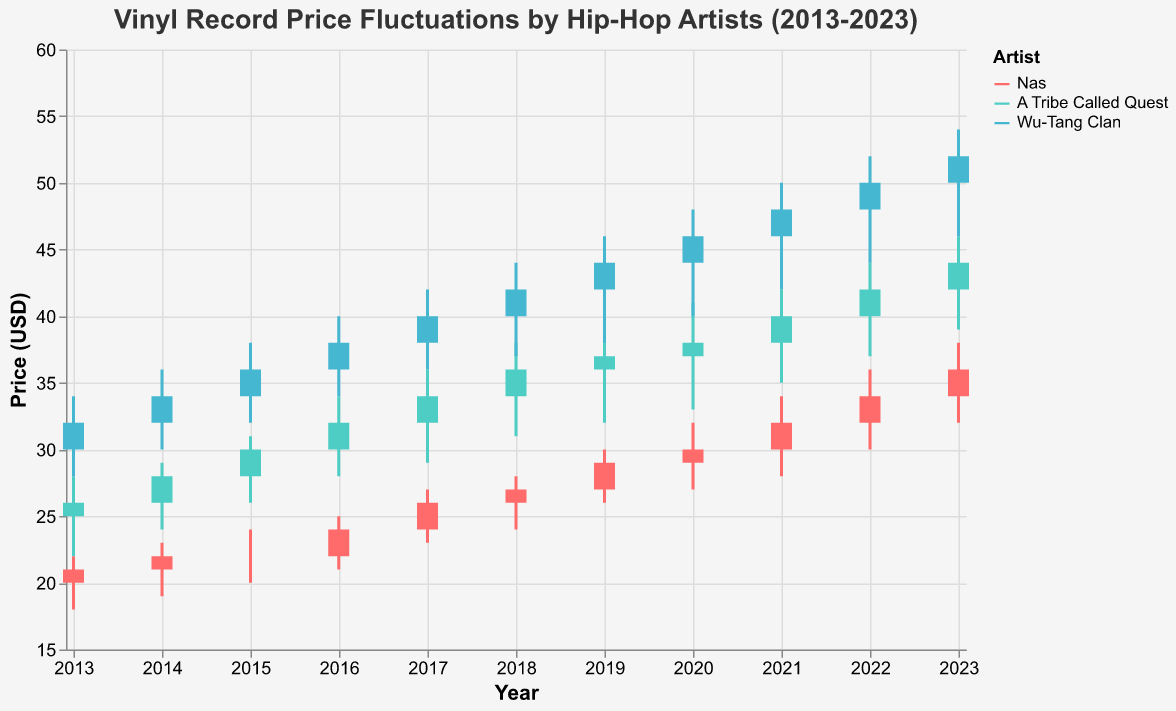How has the price of Nas's vinyl records changed from 2013 to 2023? The candlestick plot shows that in 2013, Nas's records opened at $20 and closed at $21. By 2023, they opened at $34 and closed at $36. The prices gradually increased over the past decade.
Answer: Increased from $20-$21 to $34-$36 Which artist had the highest high price for vinyl records in 2023? In 2023, Nas had a high price of $38, A Tribe Called Quest had a high price of $46, and Wu-Tang Clan had a high price of $54. Wu-Tang Clan had the highest high price.
Answer: Wu-Tang Clan What is the range of the highest and lowest prices for A Tribe Called Quest in 2020? The highest price for A Tribe Called Quest in 2020 is $41, and the lowest price is $33. The range is the difference between the highest and lowest prices, which is $41 - $33 = $8.
Answer: $8 Between Nas, A Tribe Called Quest, and Wu-Tang Clan, which artist's vinyl records had the highest closing price in 2016? Looking at the 2016 data, Nas's closing price was $24, A Tribe Called Quest's closing price was $32, and Wu-Tang Clan's closing price was $38. Wu-Tang Clan had the highest closing price.
Answer: Wu-Tang Clan What was the overall trend in vinyl record prices for Wu-Tang Clan from 2013 to 2023? The candlestick plot shows a consistent upward trend in Wu-Tang Clan's vinyl record prices from 2013 (open $30, close $32) to 2023 (open $50, close $52). The prices increased steadily each year.
Answer: Upward trend What was the average closing price of Nas's vinyl records from 2013 to 2023? To find the average closing price: sum all closing prices from 2013 to 2023 and divide by the number of years. The closing prices are $21, $22, $22, $24, $26, $27, $29, $30, $32, $34, and $36. Sum: 21 + 22 + 22 + 24 + 26 + 27 + 29 + 30 + 32 + 34 + 36 = 303. Average: 303 / 11 ≈ 27.55.
Answer: $27.55 Compare the highest closing prices of the three artists in 2023. In 2023, the closing prices are: Nas = $36, A Tribe Called Quest = $44, Wu-Tang Clan = $52. Wu-Tang Clan had the highest closing price, followed by A Tribe Called Quest, then Nas.
Answer: Wu-Tang Clan > A Tribe Called Quest > Nas 